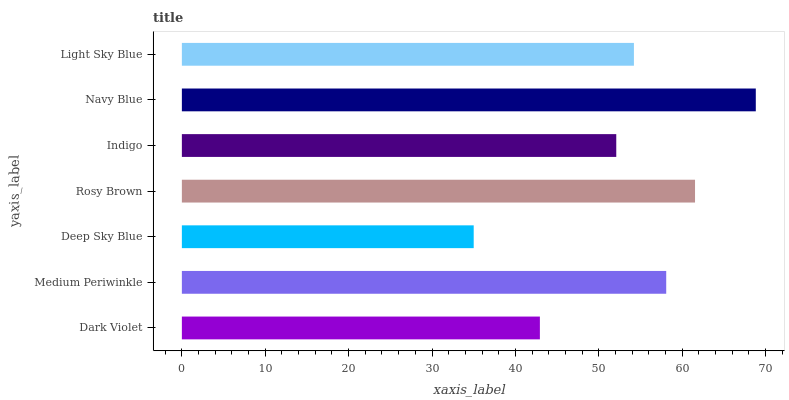Is Deep Sky Blue the minimum?
Answer yes or no. Yes. Is Navy Blue the maximum?
Answer yes or no. Yes. Is Medium Periwinkle the minimum?
Answer yes or no. No. Is Medium Periwinkle the maximum?
Answer yes or no. No. Is Medium Periwinkle greater than Dark Violet?
Answer yes or no. Yes. Is Dark Violet less than Medium Periwinkle?
Answer yes or no. Yes. Is Dark Violet greater than Medium Periwinkle?
Answer yes or no. No. Is Medium Periwinkle less than Dark Violet?
Answer yes or no. No. Is Light Sky Blue the high median?
Answer yes or no. Yes. Is Light Sky Blue the low median?
Answer yes or no. Yes. Is Deep Sky Blue the high median?
Answer yes or no. No. Is Deep Sky Blue the low median?
Answer yes or no. No. 